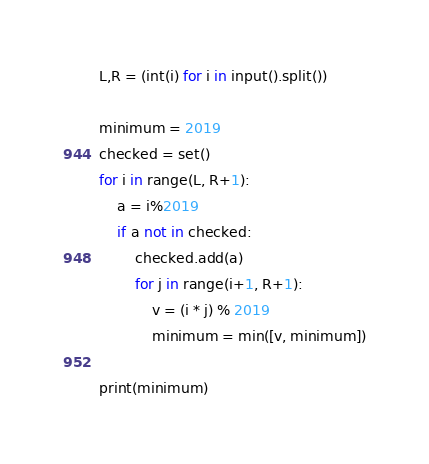<code> <loc_0><loc_0><loc_500><loc_500><_Python_>L,R = (int(i) for i in input().split())

minimum = 2019
checked = set()
for i in range(L, R+1):
    a = i%2019
    if a not in checked:
        checked.add(a)
        for j in range(i+1, R+1):
            v = (i * j) % 2019
            minimum = min([v, minimum])

print(minimum)</code> 